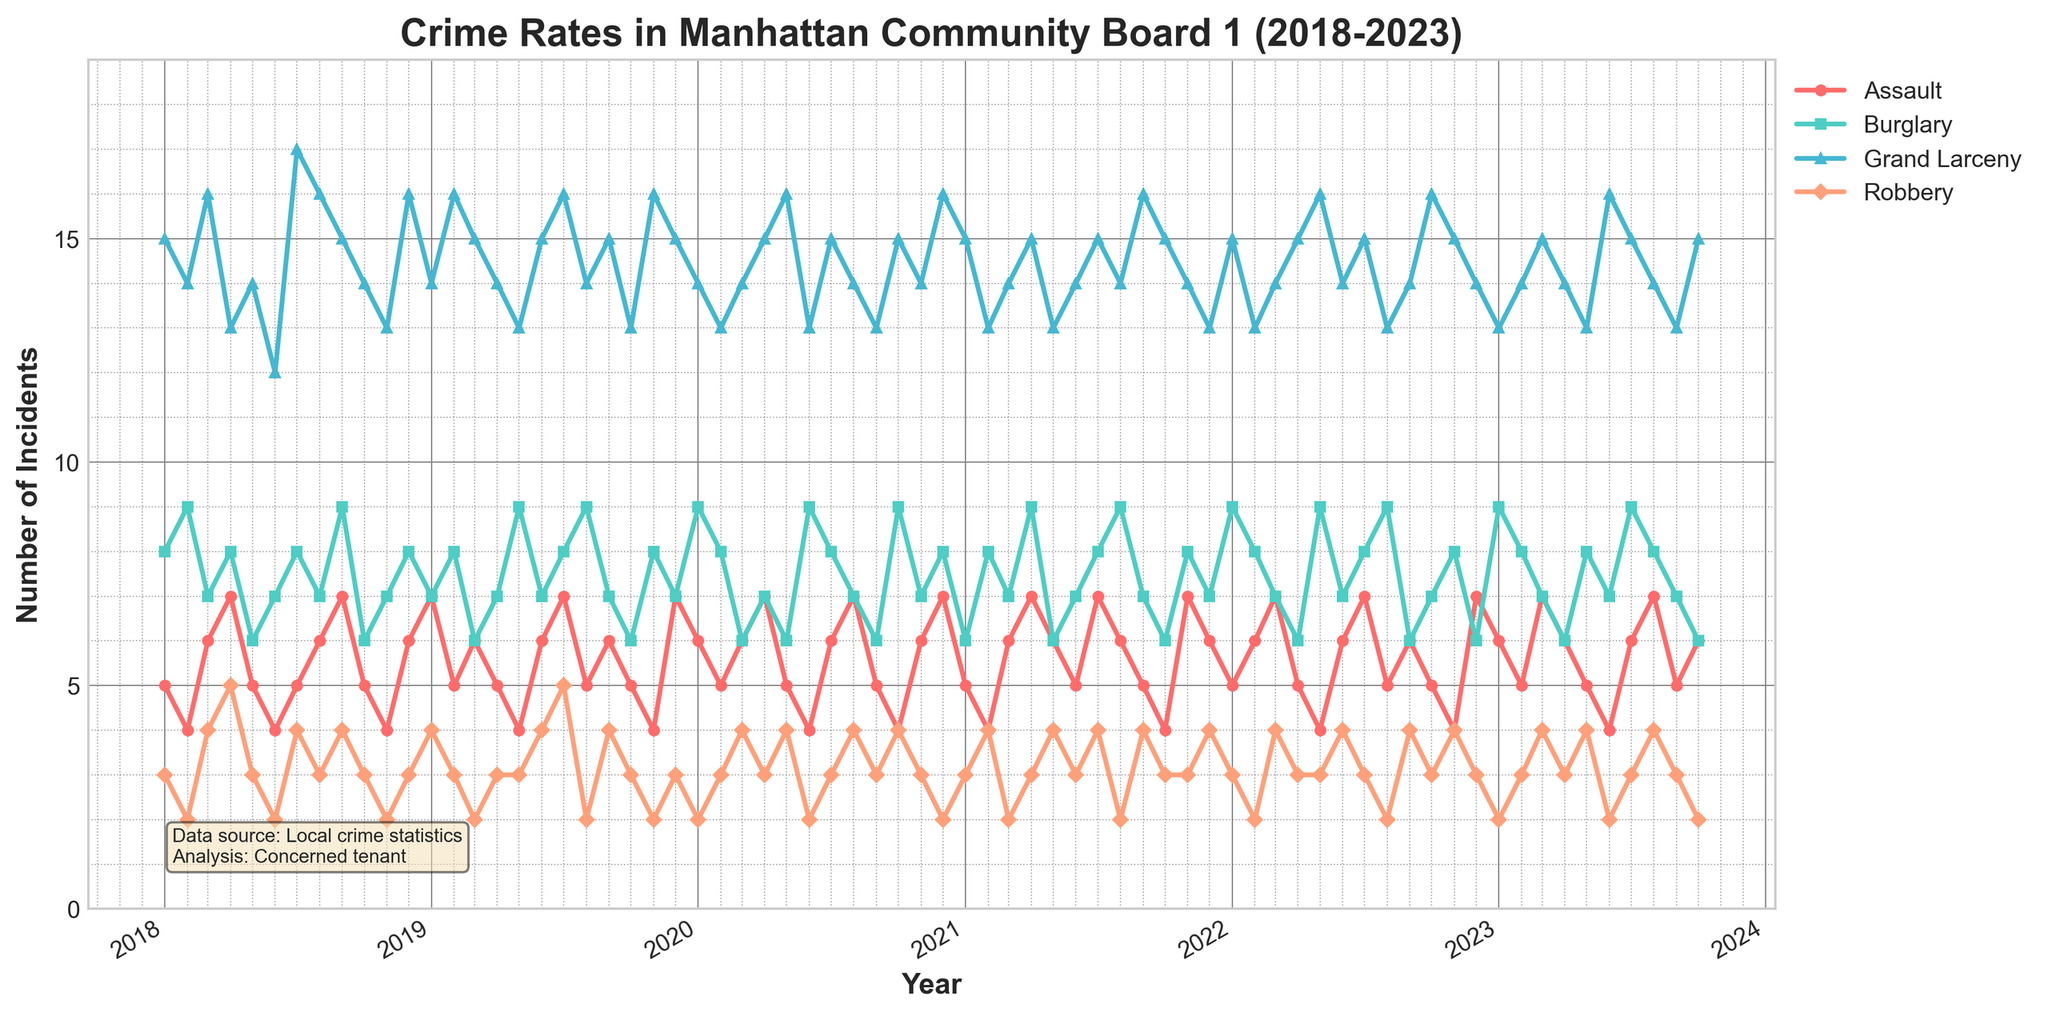What are the four types of crime rates shown in the figure? The four crime rates shown in the figure are labeled in the legend and represented by different colors and markers on the plot.
Answer: Assault, Burglary, Grand Larceny, Robbery What color is used to represent Assault incidents in the plot? The color used to represent Assault incidents can be identified by looking at the plot or the legend.
Answer: Red Which year had the highest number of Grand Larceny incidents? To find this, locate the highest point on the Grand Larceny (blue) line, and then check the corresponding year on the x-axis.
Answer: 2020 How do the number of Assault incidents in July 2020 compare to those in July 2019? Look for the points corresponding to July 2020 and July 2019 on the Assault (red) line and compare their y-values.
Answer: 6 (2020) vs 7 (2019) During which month and year was the highest number of burglary incidents reported? Search for the highest point on the Burglary (green) line and read the corresponding month and year from the x-axis.
Answer: January 2023 Which crime type shows the most fluctuation over the 5 years? Compare the overall variability or range of y-values for each crime type line in the plot.
Answer: Grand Larceny What is the average number of Robbery incidents in 2021? Sum the Robbery incidents for each month in 2021 and divide by the number of months (12).
Answer: (3+4+2+3+4+3+4+2+4+3+3+4)/12 = 3.25 Did the number of Burglary incidents increase or decrease from 2018 to 2023? Compare the number of Burglary incidents at the start (2018) and the end (2023) by looking at the y-values at those points on the Burglary line.
Answer: Increase Which crime type generally has the highest number of incidents each year? Identify the line that generally stays above the others each year.
Answer: Grand Larceny What is the trend in Assault incidents from 2018 to 2023? Observe the overall direction of the Assault line (red) from 2018 to 2023.
Answer: Fluctuating with no clear increasing or decreasing trend 